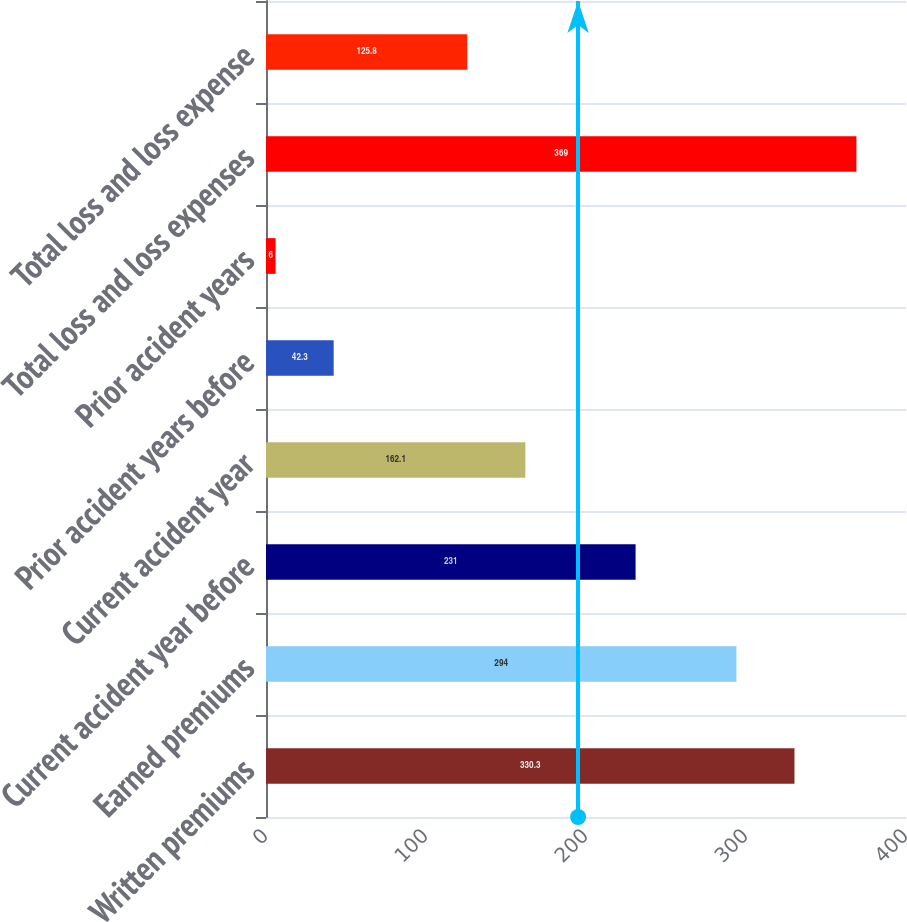Convert chart to OTSL. <chart><loc_0><loc_0><loc_500><loc_500><bar_chart><fcel>Written premiums<fcel>Earned premiums<fcel>Current accident year before<fcel>Current accident year<fcel>Prior accident years before<fcel>Prior accident years<fcel>Total loss and loss expenses<fcel>Total loss and loss expense<nl><fcel>330.3<fcel>294<fcel>231<fcel>162.1<fcel>42.3<fcel>6<fcel>369<fcel>125.8<nl></chart> 